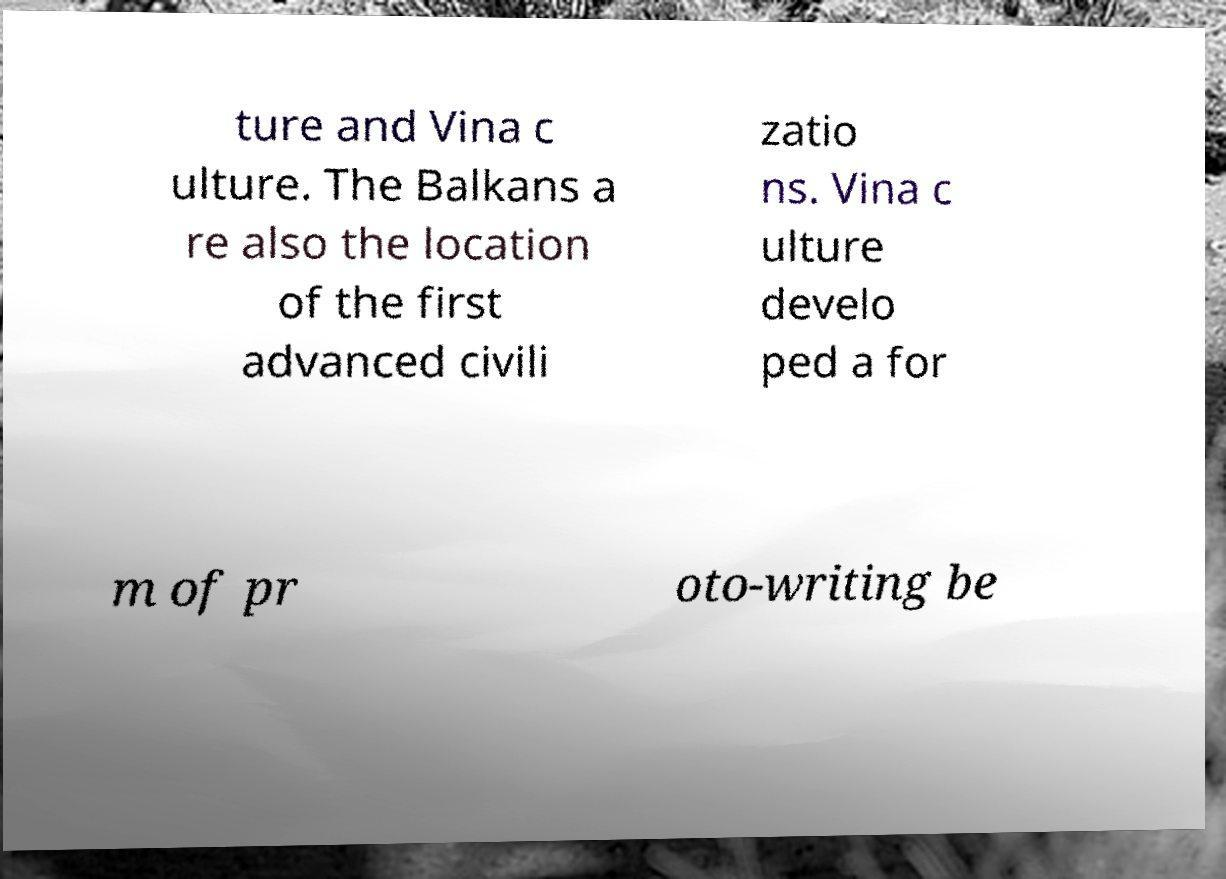Can you read and provide the text displayed in the image?This photo seems to have some interesting text. Can you extract and type it out for me? ture and Vina c ulture. The Balkans a re also the location of the first advanced civili zatio ns. Vina c ulture develo ped a for m of pr oto-writing be 